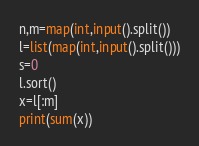<code> <loc_0><loc_0><loc_500><loc_500><_Python_>n,m=map(int,input().split())
l=list(map(int,input().split()))
s=0
l.sort()
x=l[:m]
print(sum(x))
</code> 